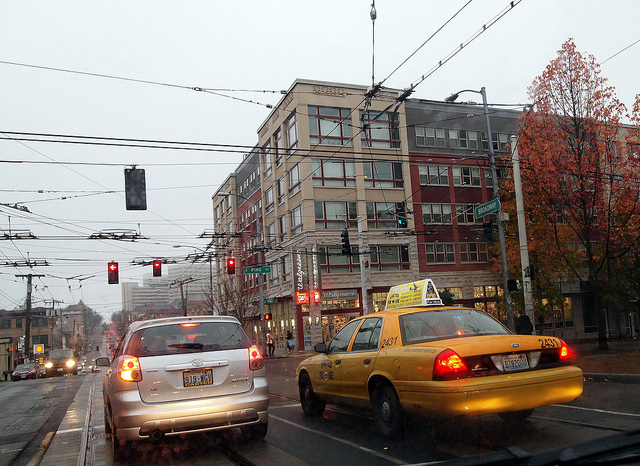Identify and read out the text in this image. 2431 